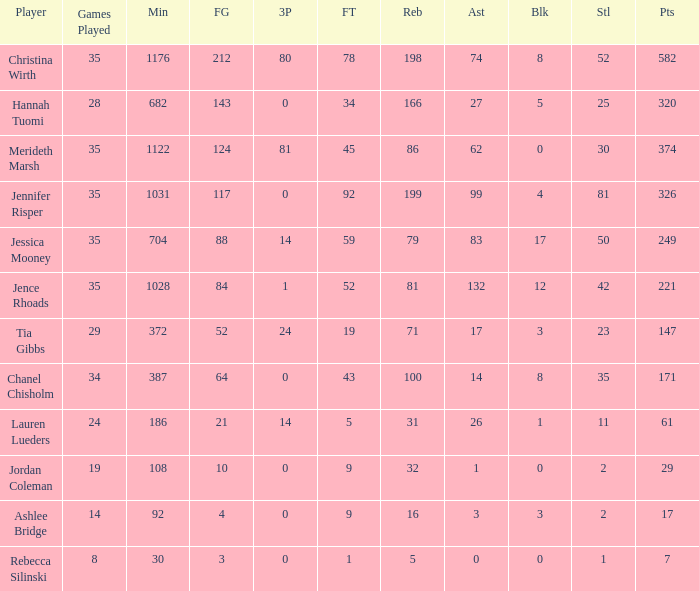What is the lowest number of 3 pointers that occured in games with 52 steals? 80.0. Would you be able to parse every entry in this table? {'header': ['Player', 'Games Played', 'Min', 'FG', '3P', 'FT', 'Reb', 'Ast', 'Blk', 'Stl', 'Pts'], 'rows': [['Christina Wirth', '35', '1176', '212', '80', '78', '198', '74', '8', '52', '582'], ['Hannah Tuomi', '28', '682', '143', '0', '34', '166', '27', '5', '25', '320'], ['Merideth Marsh', '35', '1122', '124', '81', '45', '86', '62', '0', '30', '374'], ['Jennifer Risper', '35', '1031', '117', '0', '92', '199', '99', '4', '81', '326'], ['Jessica Mooney', '35', '704', '88', '14', '59', '79', '83', '17', '50', '249'], ['Jence Rhoads', '35', '1028', '84', '1', '52', '81', '132', '12', '42', '221'], ['Tia Gibbs', '29', '372', '52', '24', '19', '71', '17', '3', '23', '147'], ['Chanel Chisholm', '34', '387', '64', '0', '43', '100', '14', '8', '35', '171'], ['Lauren Lueders', '24', '186', '21', '14', '5', '31', '26', '1', '11', '61'], ['Jordan Coleman', '19', '108', '10', '0', '9', '32', '1', '0', '2', '29'], ['Ashlee Bridge', '14', '92', '4', '0', '9', '16', '3', '3', '2', '17'], ['Rebecca Silinski', '8', '30', '3', '0', '1', '5', '0', '0', '1', '7']]} 